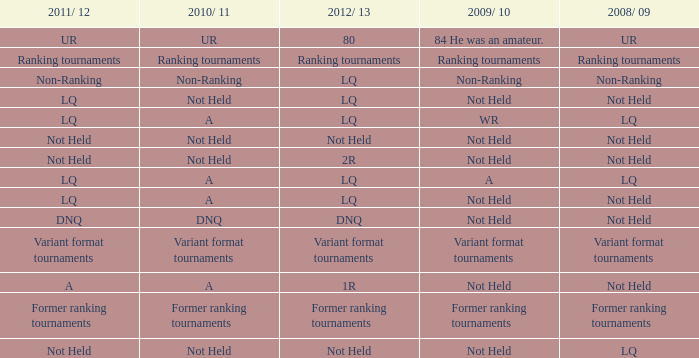When the 2008/ 09 has non-ranking what is the 2009/ 10? Non-Ranking. 